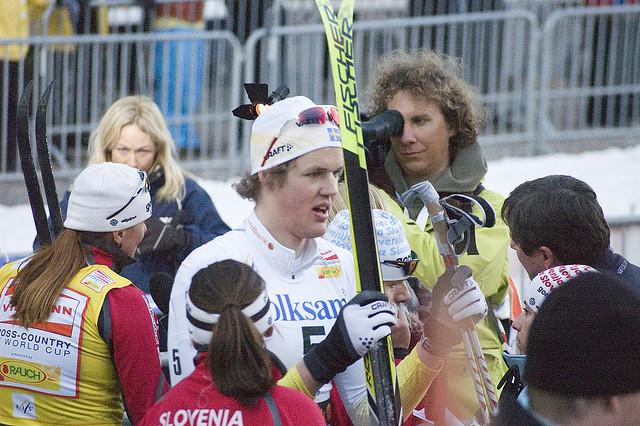What brand of skis is the guy in the white shirt holding?
Keep it brief. Fischer. What sport do these children play?
Answer briefly. Skiing. Are the people dressed for warm weather or cold weather?
Be succinct. Cold. What sport does this athlete play professionally?
Be succinct. Skiing. How many people are wearing hats?
Quick response, please. 5. 